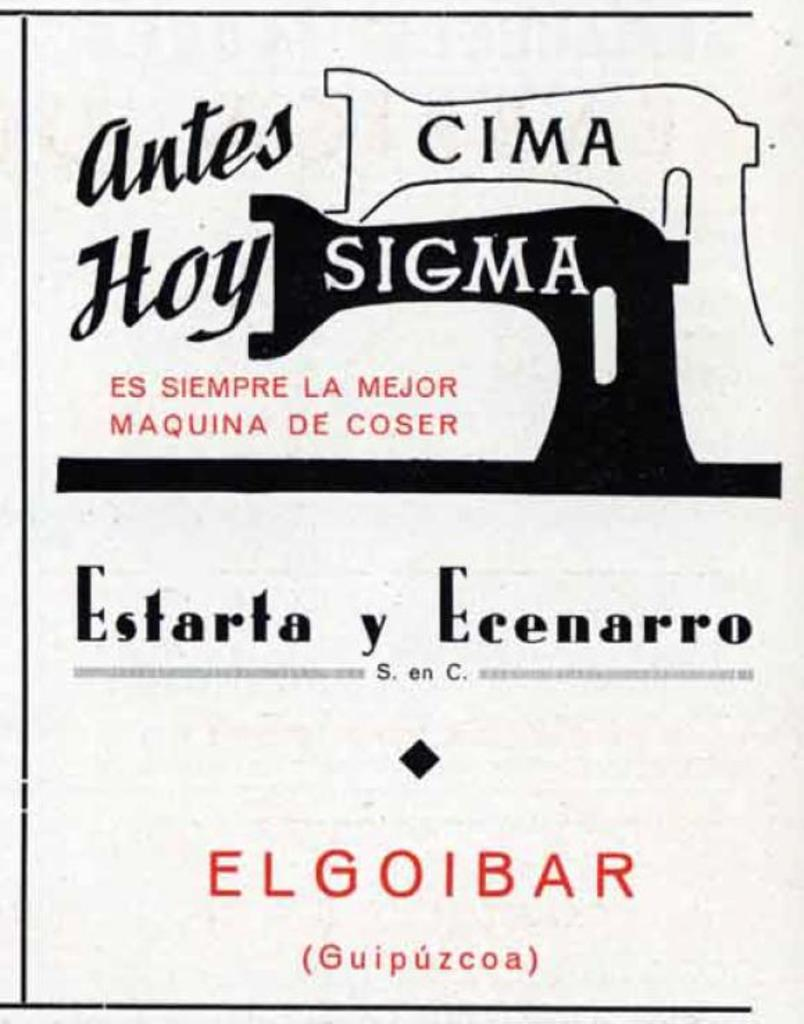<image>
Describe the image concisely. an ad saying Antes Cima Hoy Sigma on the top. 